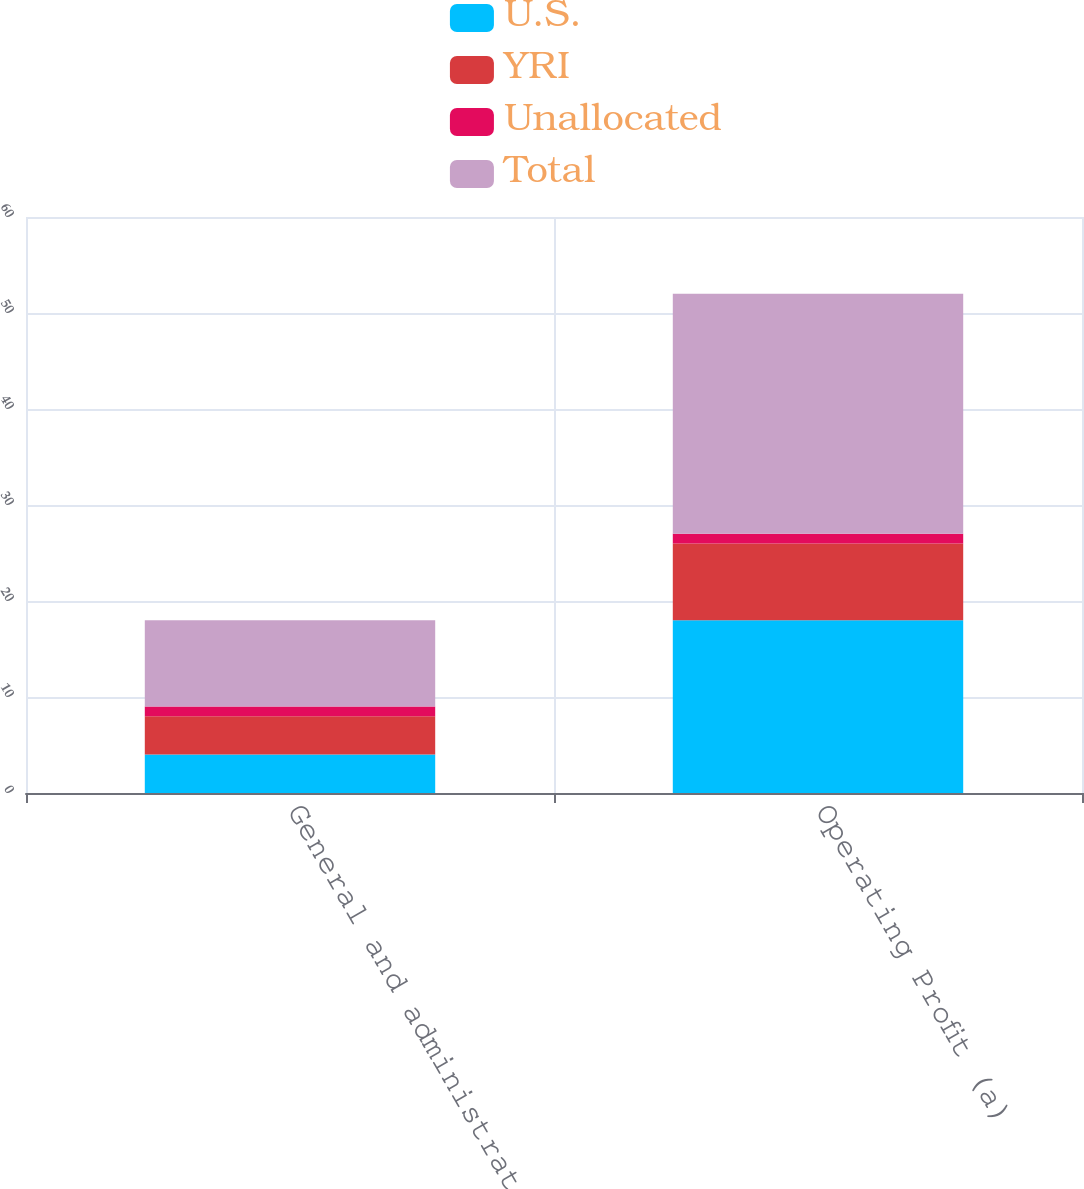Convert chart. <chart><loc_0><loc_0><loc_500><loc_500><stacked_bar_chart><ecel><fcel>General and administrative<fcel>Operating Profit (a)<nl><fcel>U.S.<fcel>4<fcel>18<nl><fcel>YRI<fcel>4<fcel>8<nl><fcel>Unallocated<fcel>1<fcel>1<nl><fcel>Total<fcel>9<fcel>25<nl></chart> 